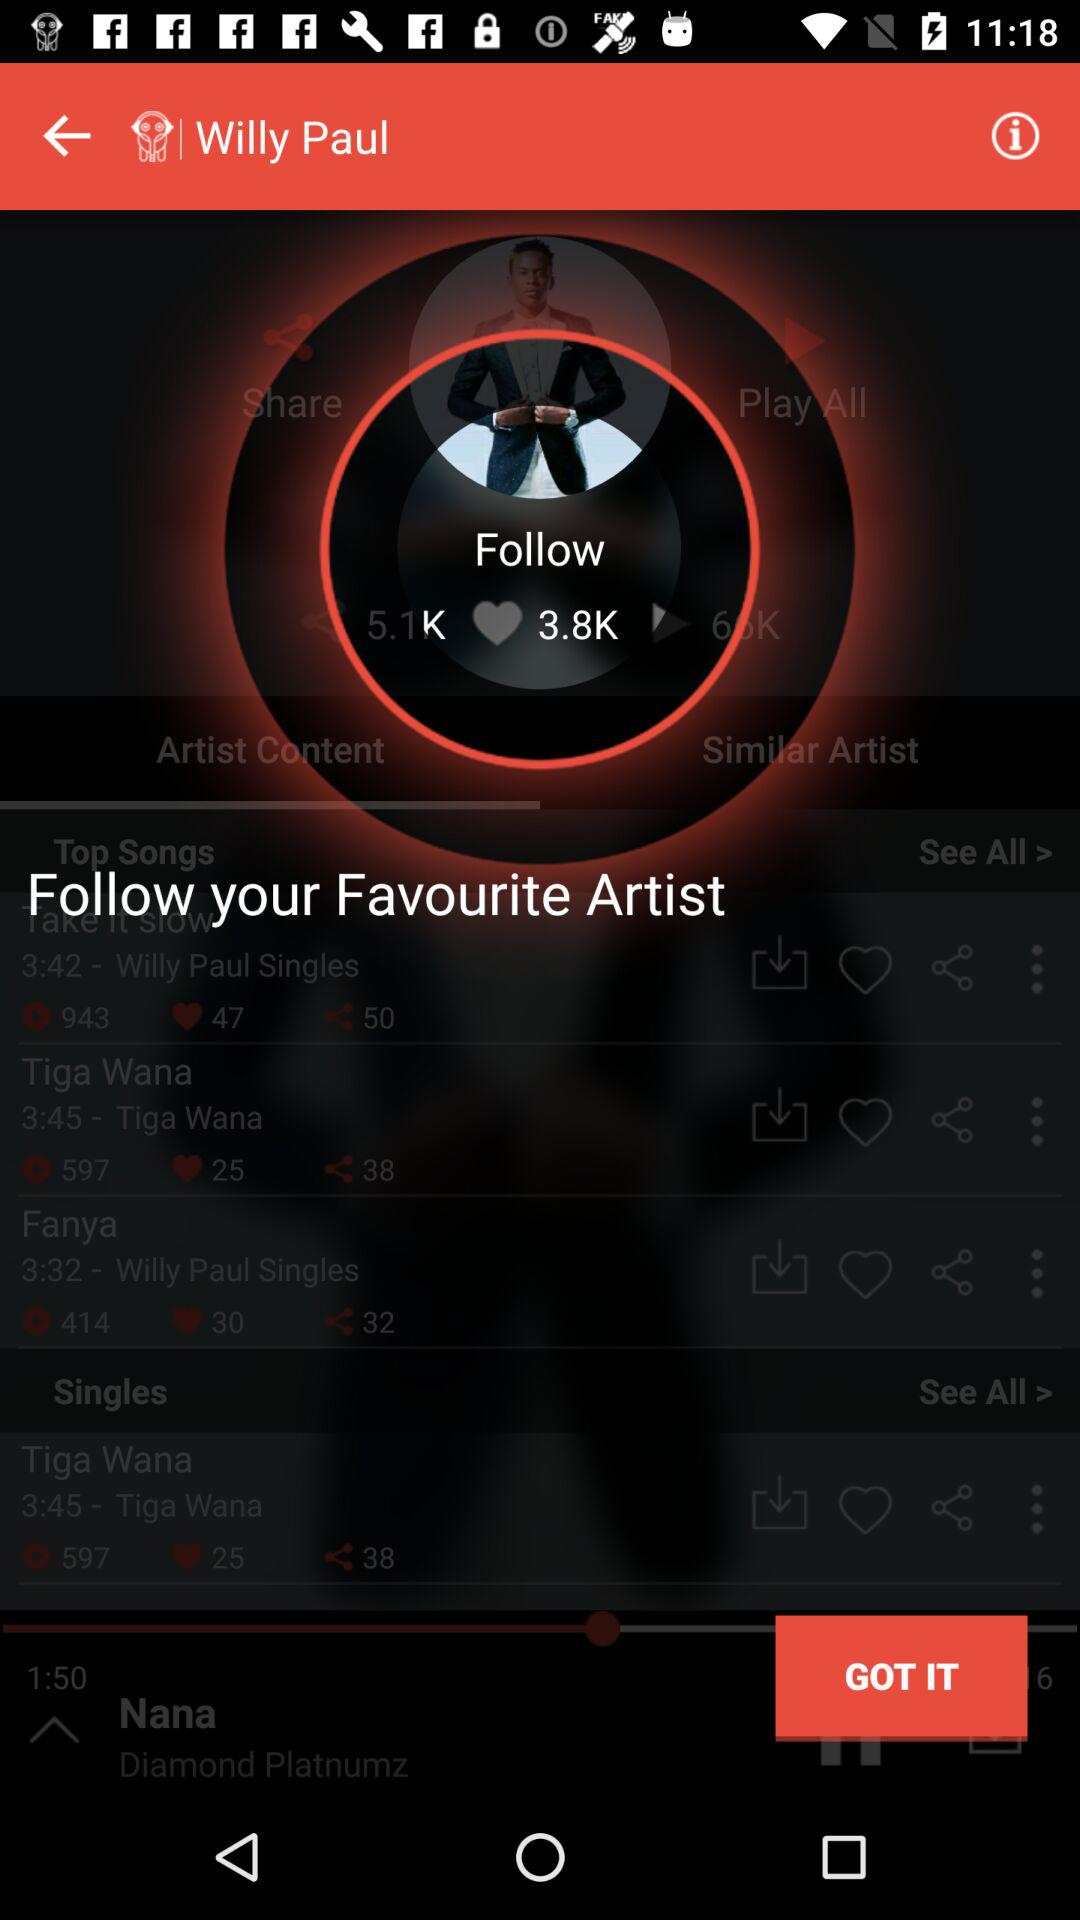What is the application Name?
When the provided information is insufficient, respond with <no answer>. <no answer> 